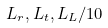Convert formula to latex. <formula><loc_0><loc_0><loc_500><loc_500>L _ { r } , L _ { t } , L _ { L } / 1 0</formula> 